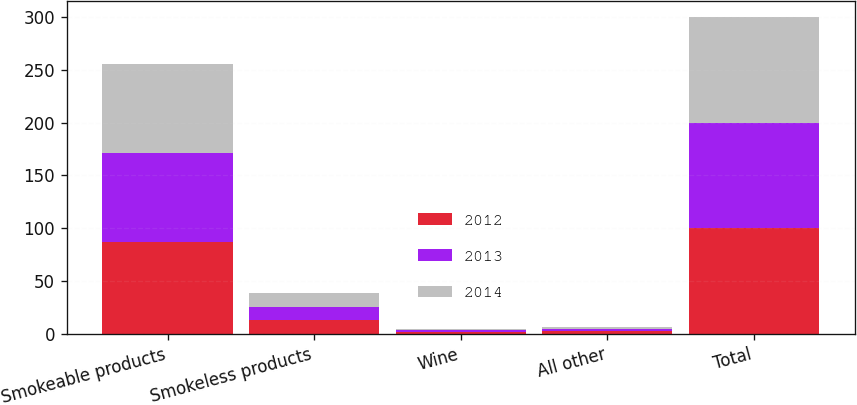Convert chart to OTSL. <chart><loc_0><loc_0><loc_500><loc_500><stacked_bar_chart><ecel><fcel>Smokeable products<fcel>Smokeless products<fcel>Wine<fcel>All other<fcel>Total<nl><fcel>2012<fcel>87.2<fcel>13.4<fcel>1.7<fcel>2.3<fcel>100<nl><fcel>2013<fcel>84.5<fcel>12.2<fcel>1.4<fcel>1.9<fcel>100<nl><fcel>2014<fcel>83.7<fcel>12.5<fcel>1.4<fcel>2.4<fcel>100<nl></chart> 